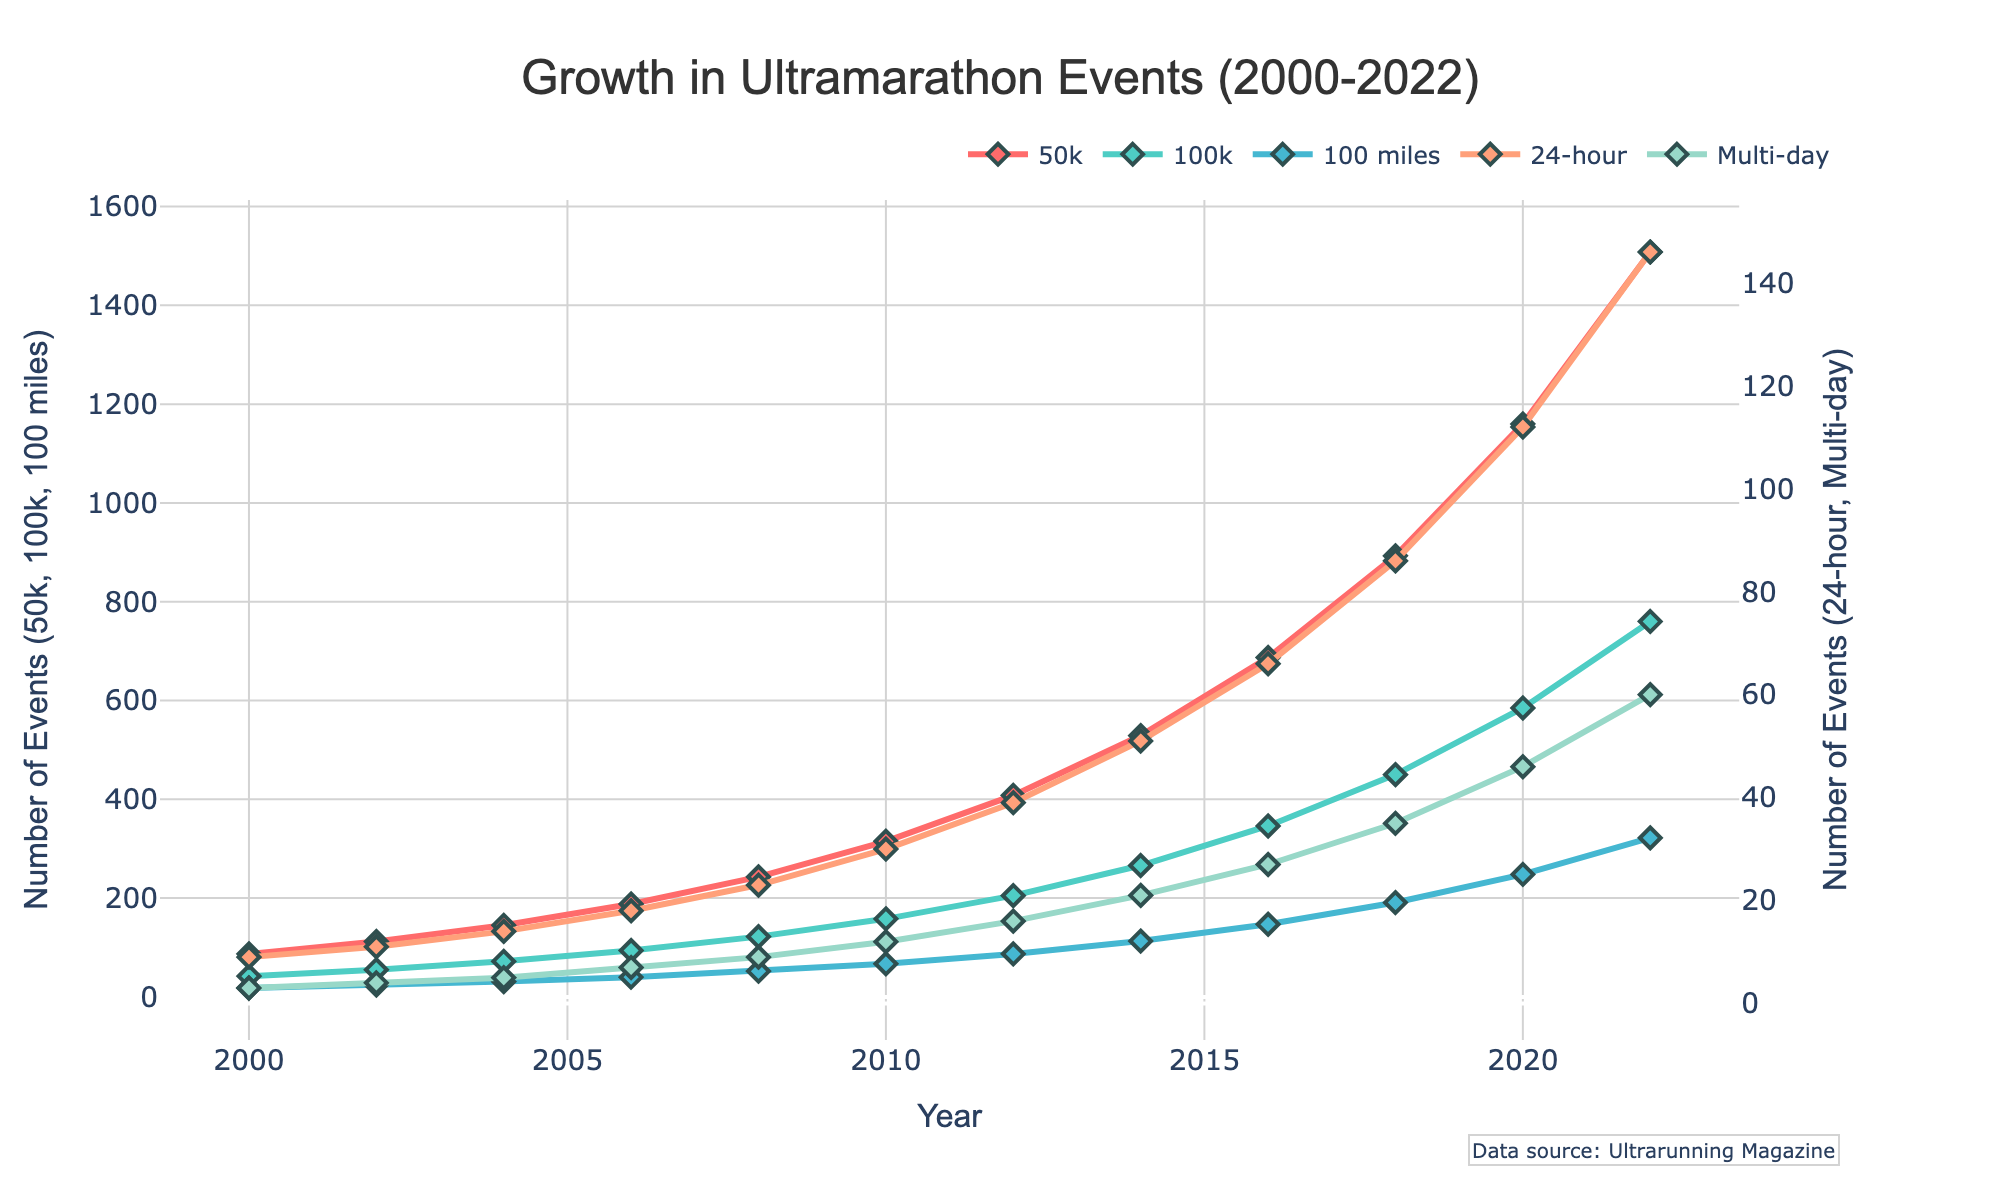What's the general trend in the number of registered ultramarathon events for the 50k category from 2000 to 2022? By examining the plotted line for the 50k category, you can see that it steadily increases over time from 87 events in 2000 to 1508 events in 2022. This indicates a growing trend in the number of 50k events over the years.
Answer: Increasing Which category had the largest growth in the number of events between 2000 and 2022? Compare the starting and ending values for each category to find the largest difference. For the 50k category, the growth is 1508 - 87 = 1421. For the 100k category, it is 760 - 42 = 718. For the 100 miles category, it is 322 - 18 = 304. For the 24-hour category, it is 146 - 9 = 137. For the Multi-day category, it is 60 - 3 = 57. The 50k category shows the largest growth.
Answer: 50k In which year did the number of 100k events first surpass 200? Trace the line for the 100k category and find the first year the count exceeds 200. The 100k category rises from 158 in 2010 to 205 in 2012. Thus, it surpasses 200 in 2012.
Answer: 2012 How does the growth rate of 24-hour events compare with that of Multi-day events from 2000 to 2022? Calculate the initial and final counts for both categories: 24-hour: 146 - 9 = 137, Multi-day: 60 - 3 = 57. The growth in the number of events is greater for 24-hour events.
Answer: Higher for 24-hour What is the difference in the number of 50k and 100 miles events in 2018? Look at the data points for both categories in 2018. The number of events for 50k is 893, and for 100 miles is 191. The difference is 893 - 191 = 702.
Answer: 702 Which category had the slowest growth rate from 2000 to 2022? By examining the growth differences calculated previously (50k: 1421, 100k: 718, 100 miles: 304, 24-hour: 137, Multi-day: 57), the Multi-day category has the smallest growth, indicating the slowest growth rate.
Answer: Multi-day Is there any year where the number of 100 miles events reached or surpassed the number of 24-hour events? Compare the values for the 100 miles and 24-hour events for each year. The data shows that in all years, the number of 24-hour events was never reached or surpassed by 100 miles events.
Answer: No How much did the number of 100k events increase between 2010 and 2022? Find the values for 100k events in 2010 and 2022, which are 158 and 760 respectively. The increase is 760 - 158 = 602.
Answer: 602 